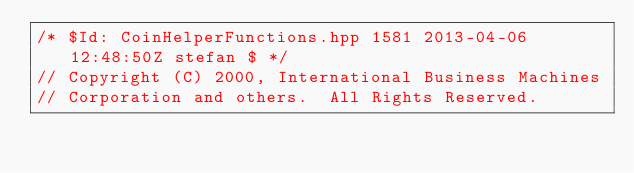<code> <loc_0><loc_0><loc_500><loc_500><_C++_>/* $Id: CoinHelperFunctions.hpp 1581 2013-04-06 12:48:50Z stefan $ */
// Copyright (C) 2000, International Business Machines
// Corporation and others.  All Rights Reserved.</code> 